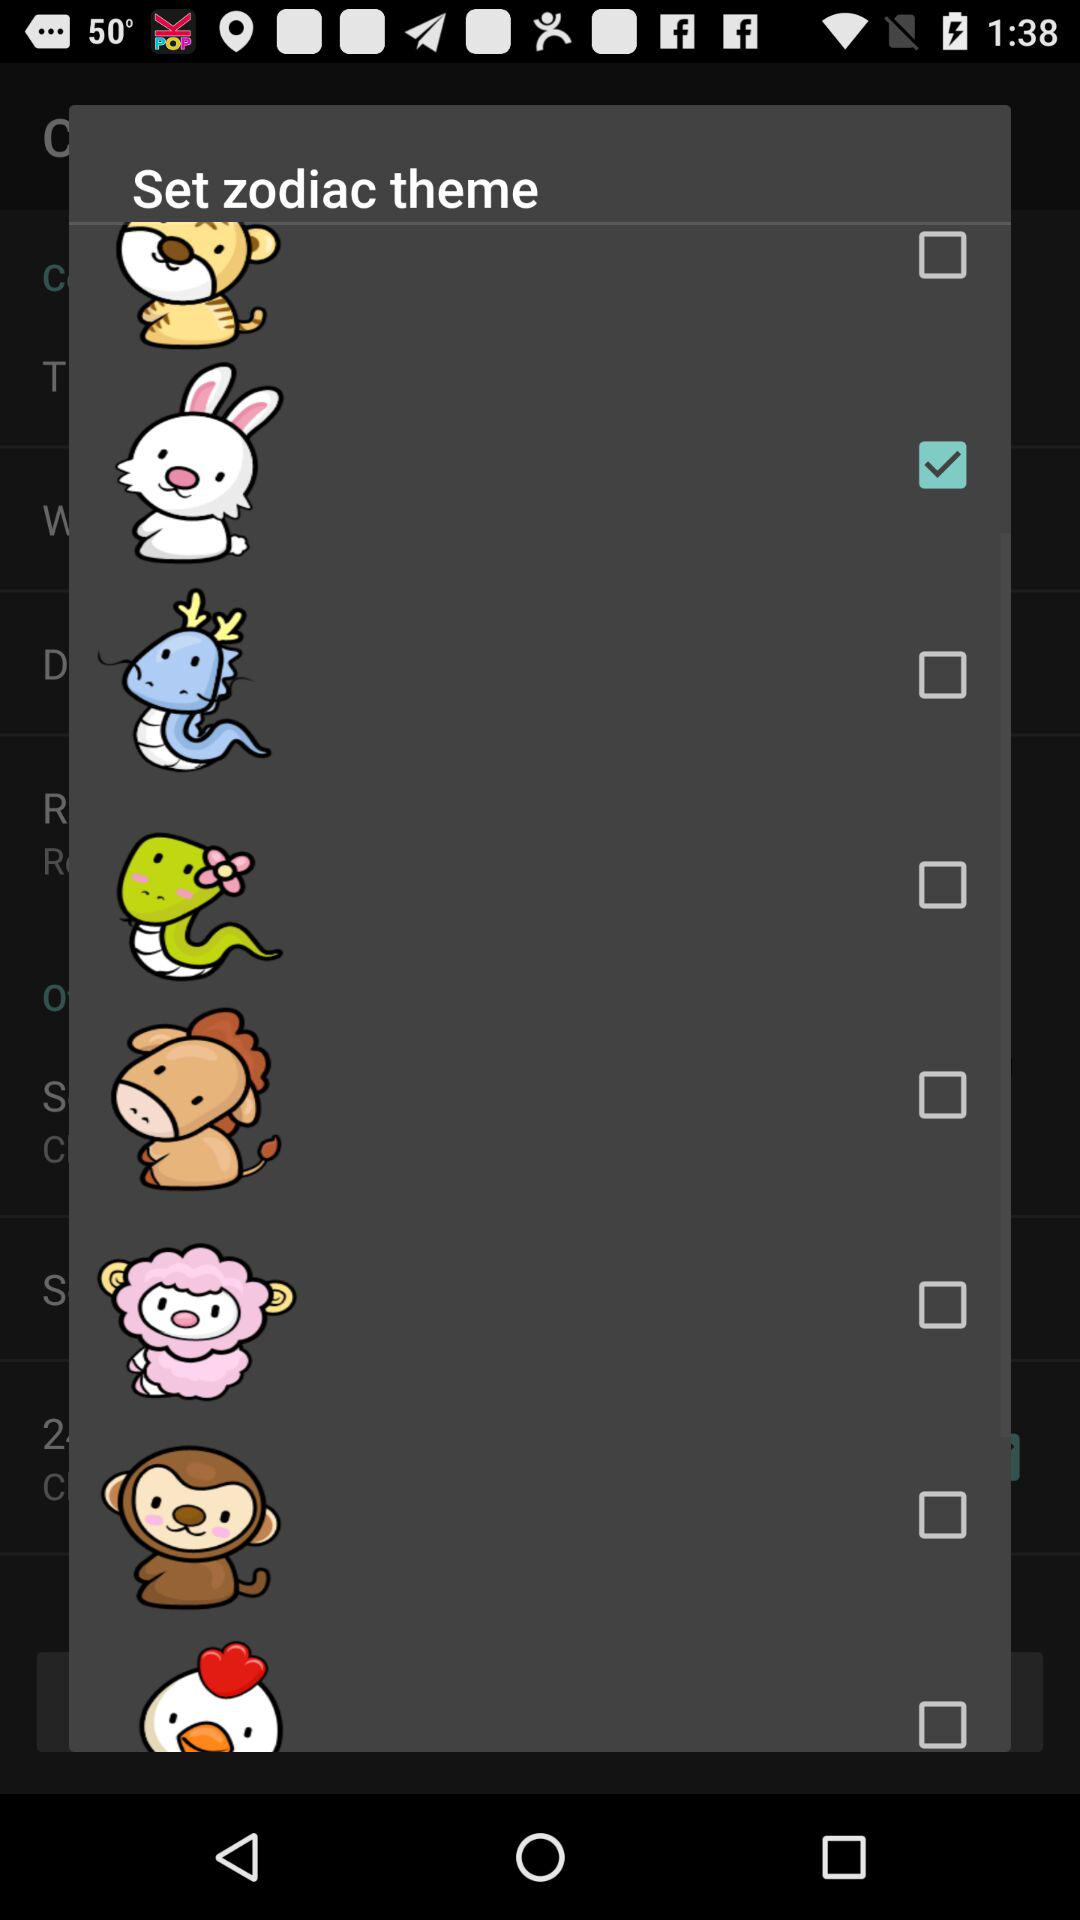How many checkboxes are in the zodiac theme screen?
Answer the question using a single word or phrase. 8 